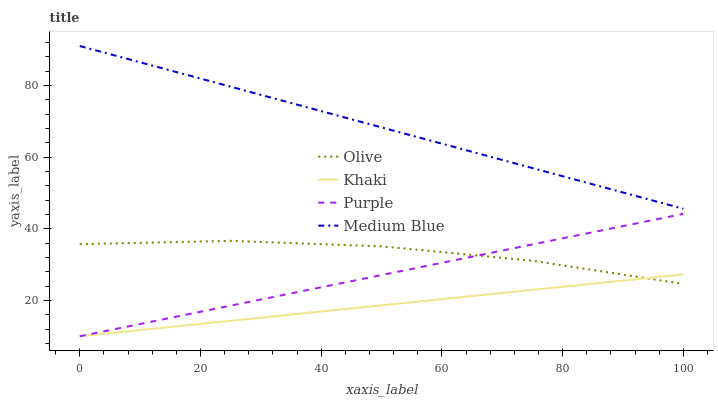Does Khaki have the minimum area under the curve?
Answer yes or no. Yes. Does Medium Blue have the maximum area under the curve?
Answer yes or no. Yes. Does Purple have the minimum area under the curve?
Answer yes or no. No. Does Purple have the maximum area under the curve?
Answer yes or no. No. Is Medium Blue the smoothest?
Answer yes or no. Yes. Is Olive the roughest?
Answer yes or no. Yes. Is Purple the smoothest?
Answer yes or no. No. Is Purple the roughest?
Answer yes or no. No. Does Purple have the lowest value?
Answer yes or no. Yes. Does Medium Blue have the lowest value?
Answer yes or no. No. Does Medium Blue have the highest value?
Answer yes or no. Yes. Does Purple have the highest value?
Answer yes or no. No. Is Olive less than Medium Blue?
Answer yes or no. Yes. Is Medium Blue greater than Olive?
Answer yes or no. Yes. Does Khaki intersect Olive?
Answer yes or no. Yes. Is Khaki less than Olive?
Answer yes or no. No. Is Khaki greater than Olive?
Answer yes or no. No. Does Olive intersect Medium Blue?
Answer yes or no. No. 